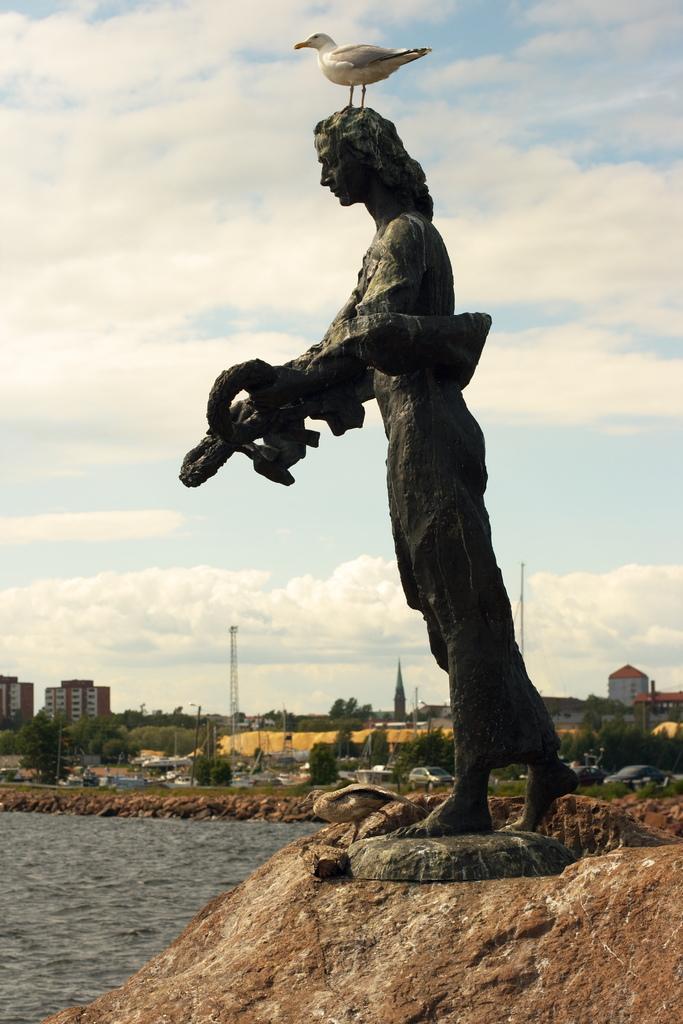In one or two sentences, can you explain what this image depicts? In the center of the image there is a bird on the statue. At the bottom there is a rock. In the background we can see water, buildings, trees, towers, grass, sky and clouds. 